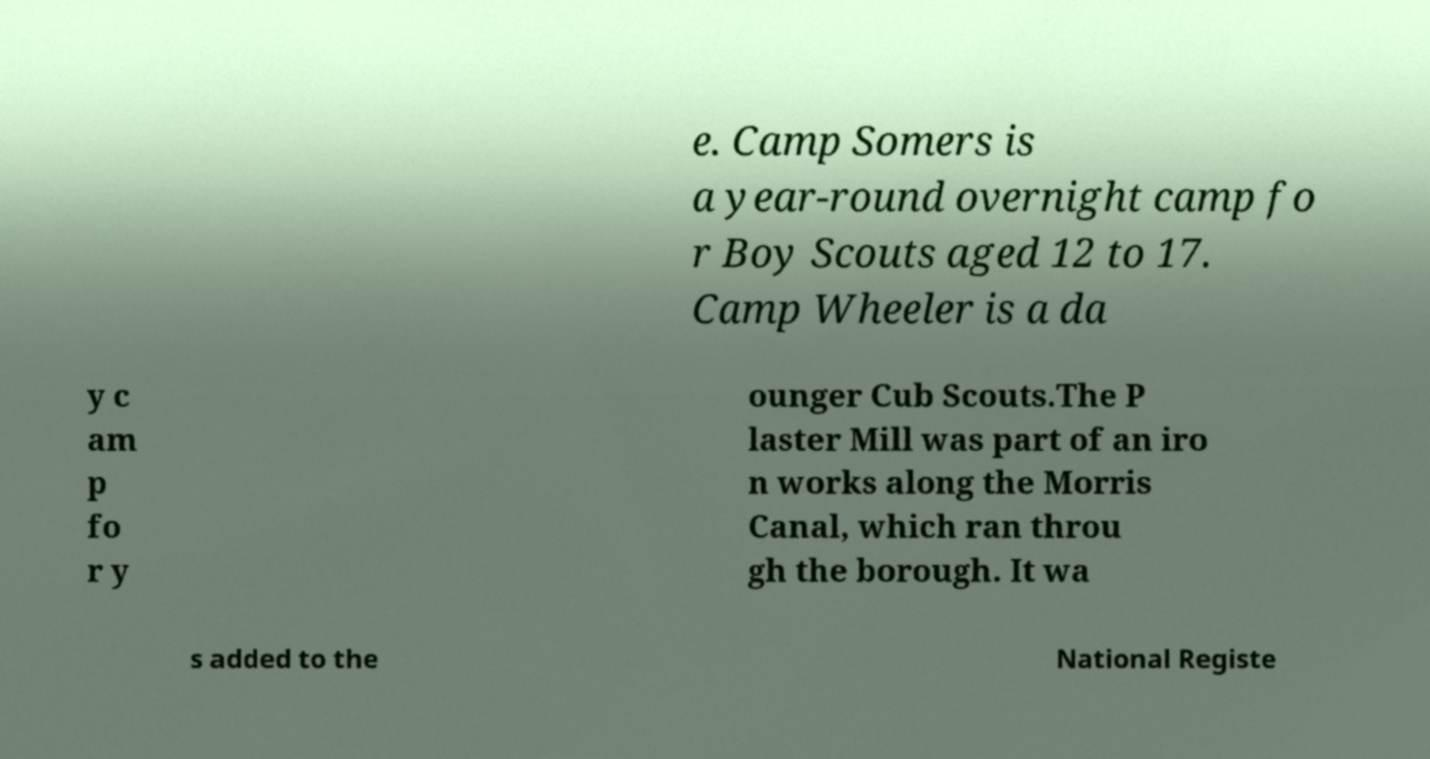Could you assist in decoding the text presented in this image and type it out clearly? e. Camp Somers is a year-round overnight camp fo r Boy Scouts aged 12 to 17. Camp Wheeler is a da y c am p fo r y ounger Cub Scouts.The P laster Mill was part of an iro n works along the Morris Canal, which ran throu gh the borough. It wa s added to the National Registe 